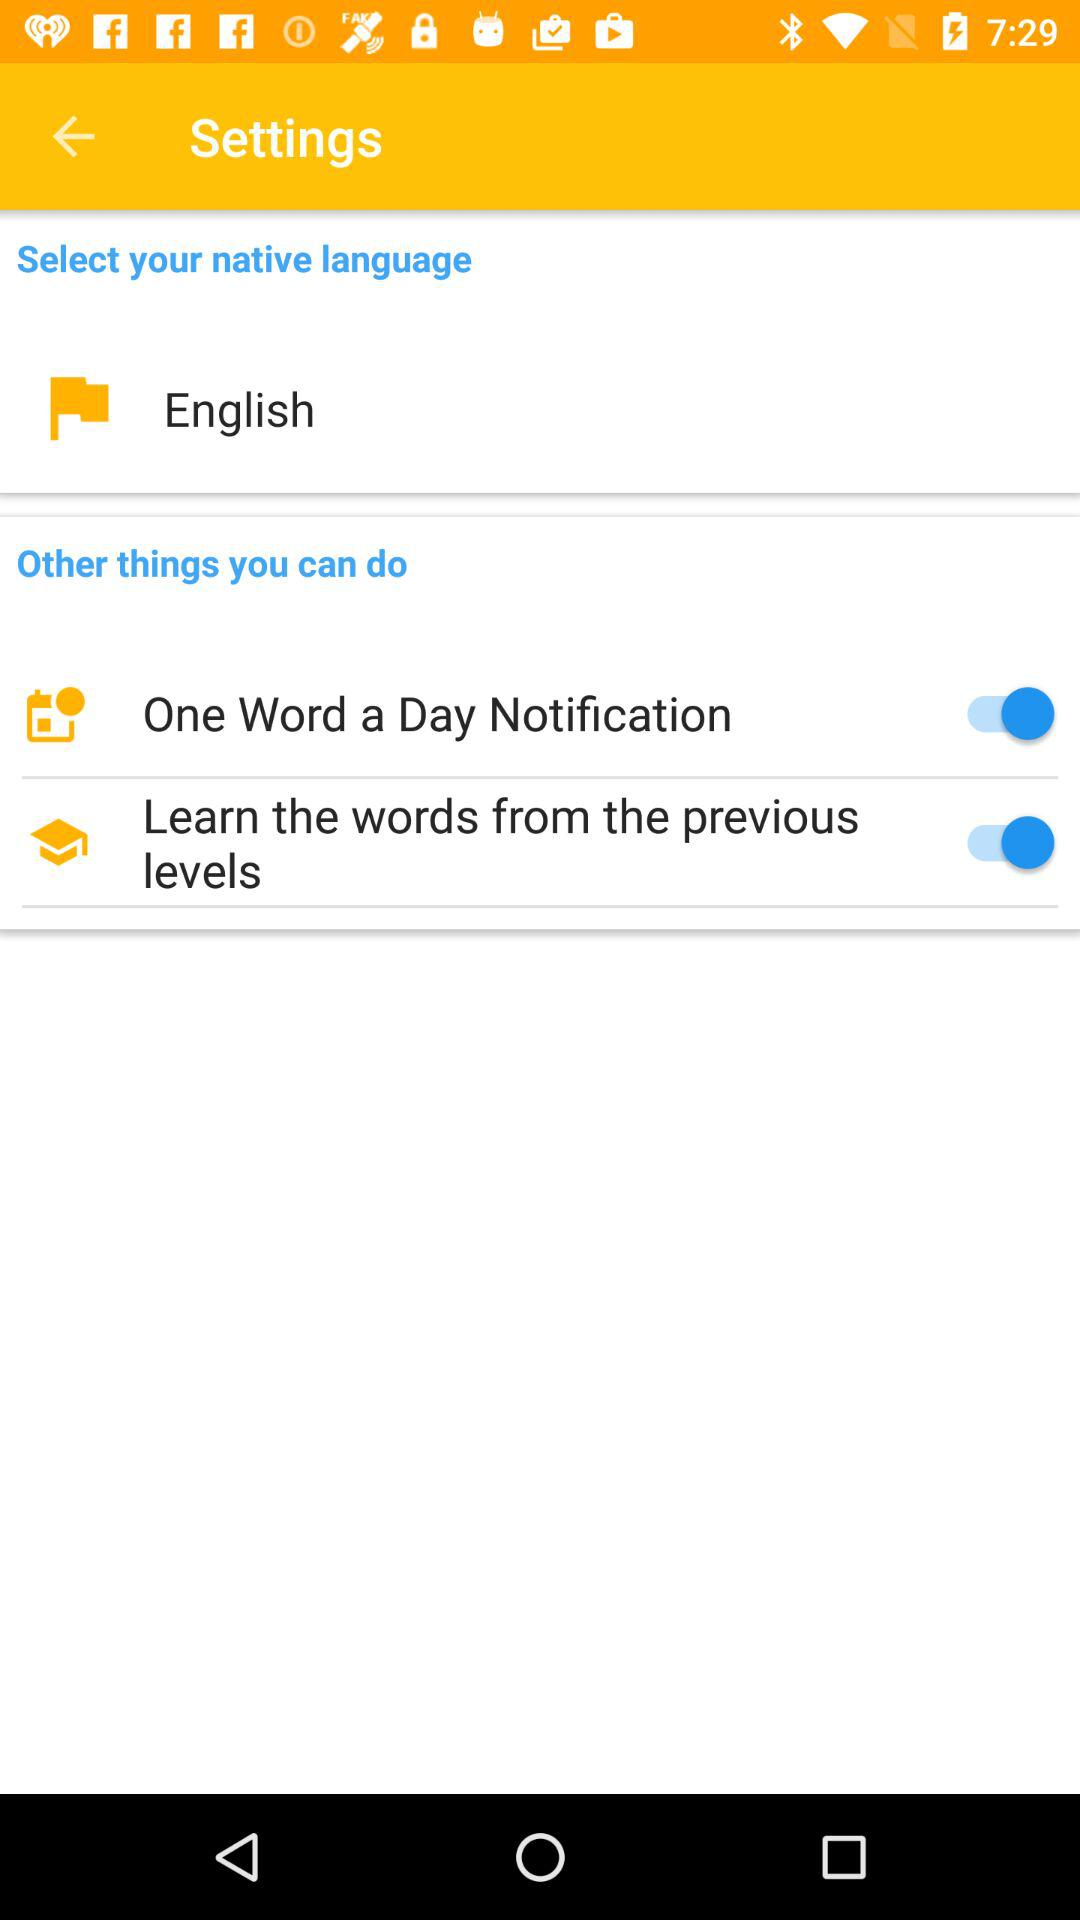Which language is selected? The selected language is English. 